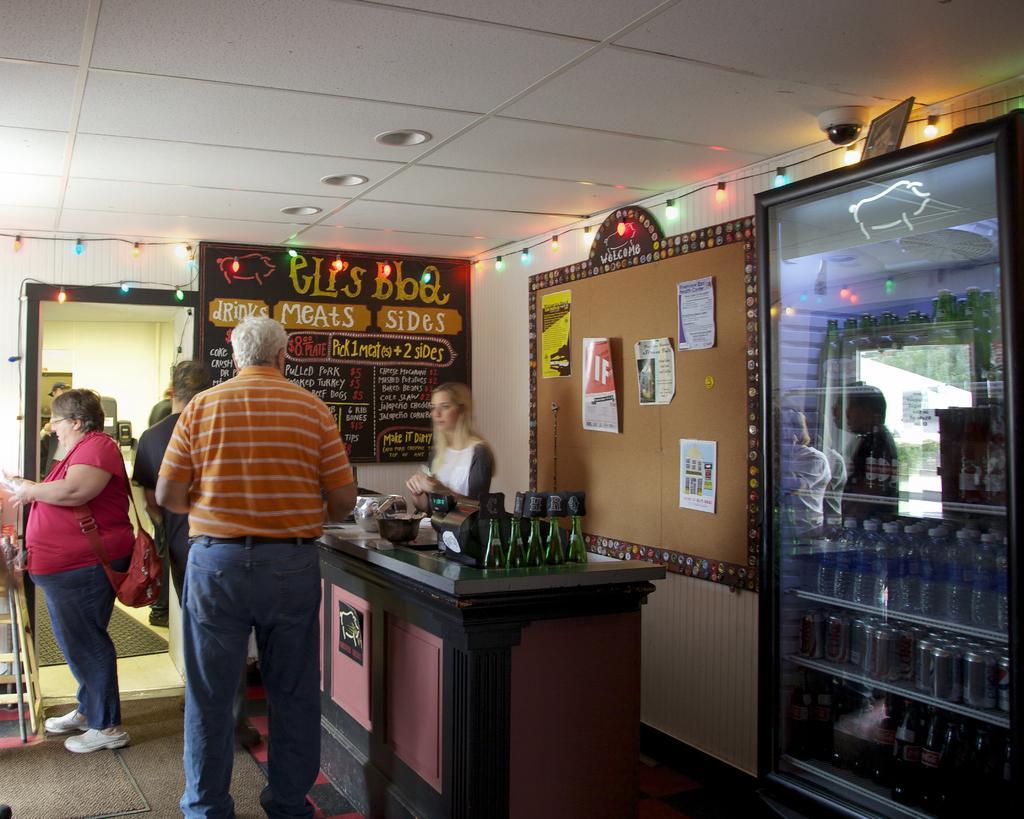Could you give a brief overview of what you see in this image? there are many person standing in a shop 